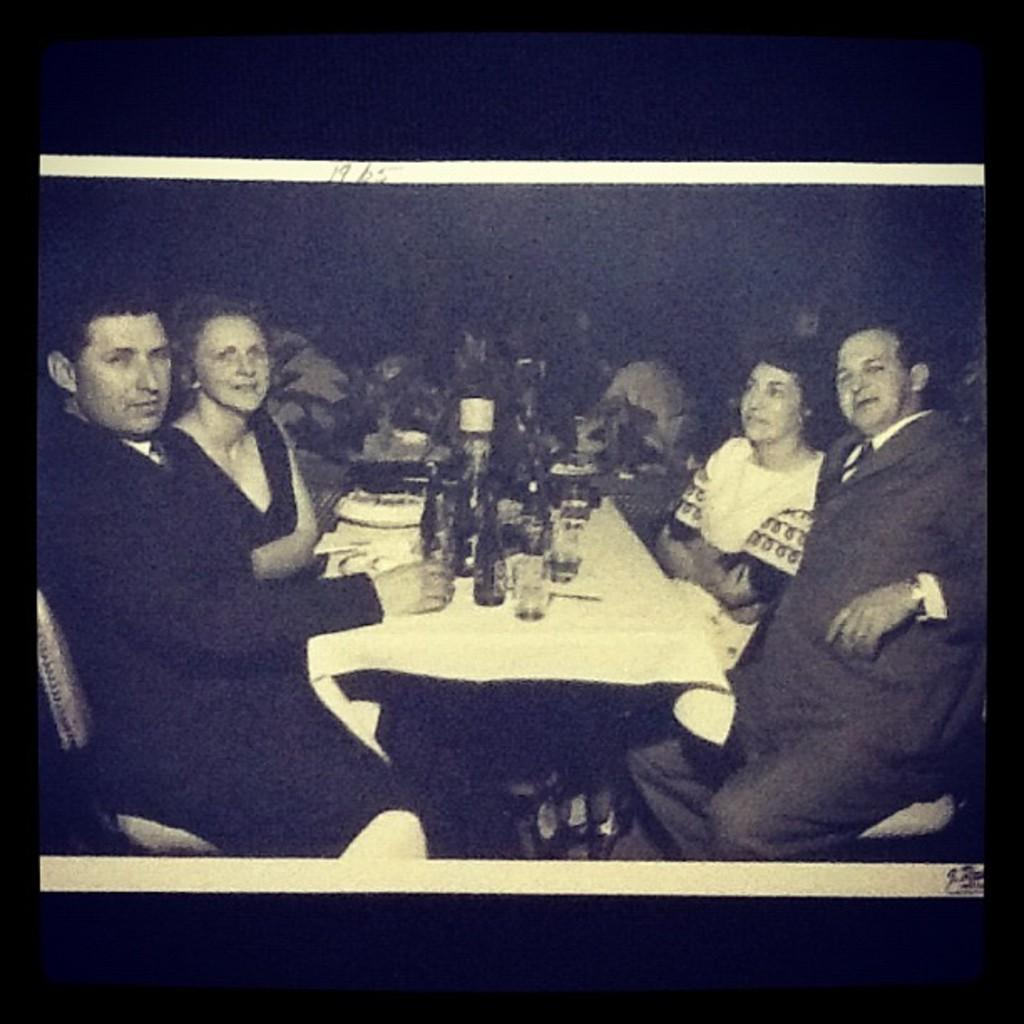What is the main subject of the image? There is a picture in the image. What is located in the center of the image? There is a table in the center of the image. What objects are on the table? There is a bottle and glasses on the table. Where are the people sitting in the image? There are people sitting on chairs on both the left and right sides of the image. What type of harmony is being played by the daughter in the image? There is no daughter present in the image, nor is there any music or harmony being played. 